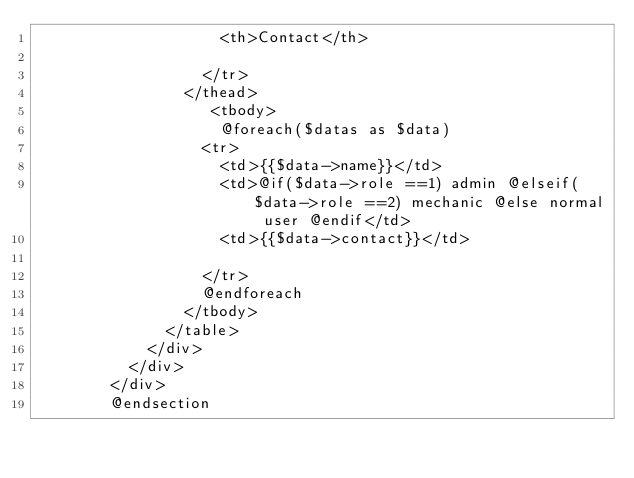Convert code to text. <code><loc_0><loc_0><loc_500><loc_500><_PHP_>                    <th>Contact</th>
                 
                  </tr>
                </thead>
                   <tbody>
                    @foreach($datas as $data)
                  <tr>
                    <td>{{$data->name}}</td>
                    <td>@if($data->role ==1) admin @elseif($data->role ==2) mechanic @else normal user @endif</td>
                    <td>{{$data->contact}}</td>
                  
                  </tr>
                  @endforeach
                </tbody>
              </table>
            </div>
          </div>
        </div>
        @endsection</code> 